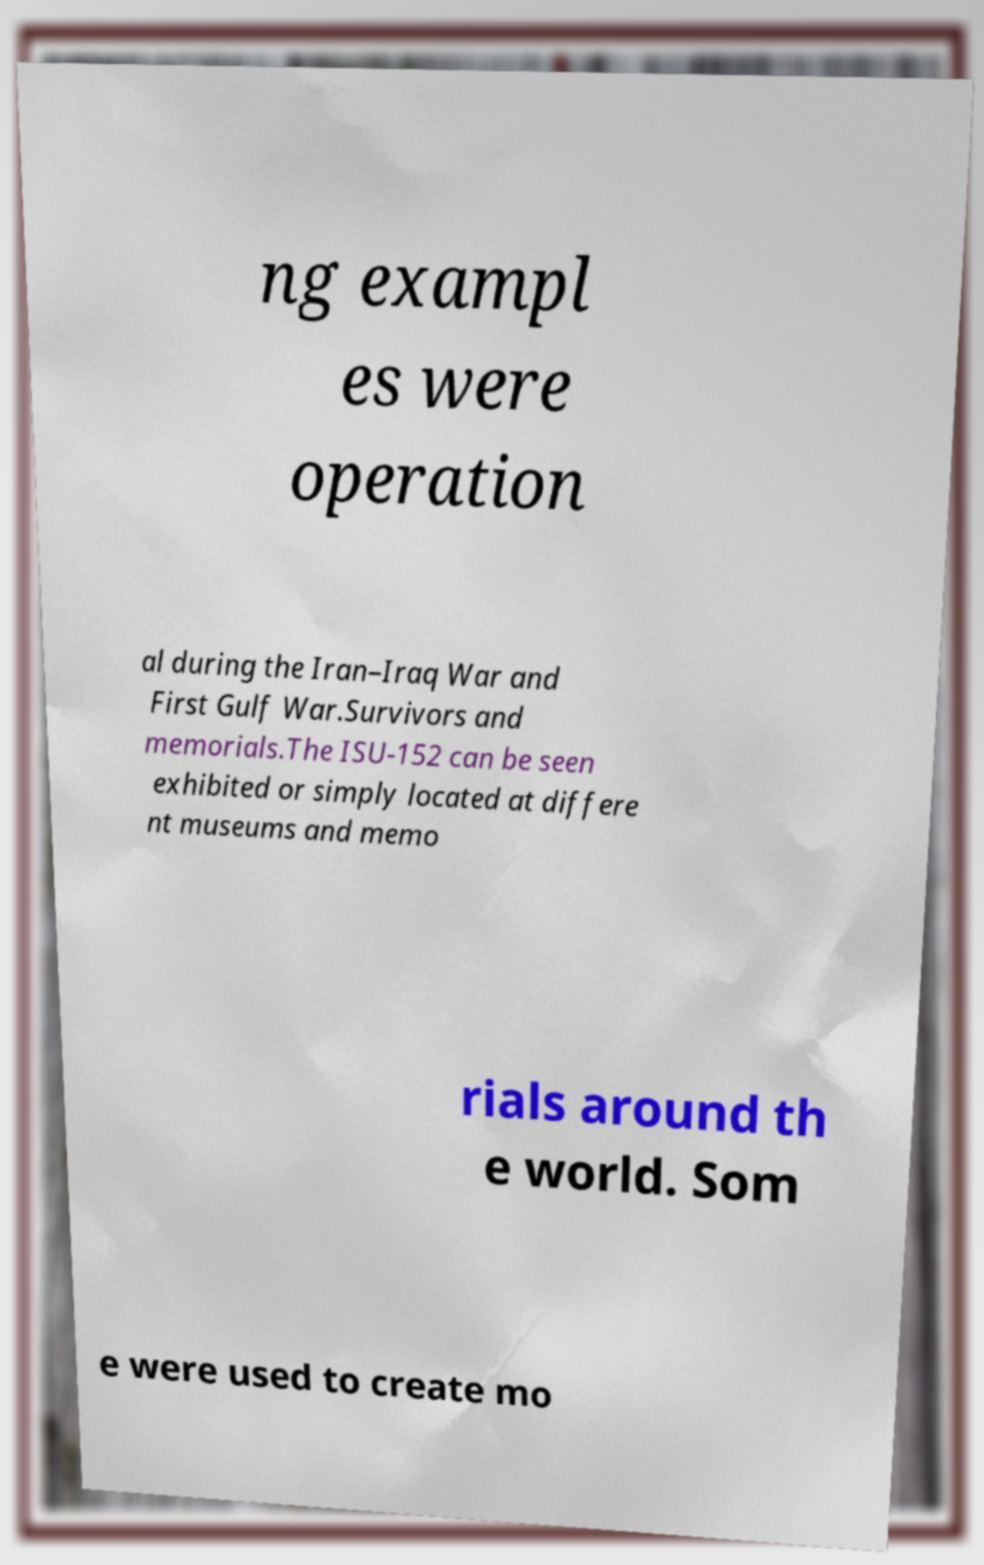I need the written content from this picture converted into text. Can you do that? ng exampl es were operation al during the Iran–Iraq War and First Gulf War.Survivors and memorials.The ISU-152 can be seen exhibited or simply located at differe nt museums and memo rials around th e world. Som e were used to create mo 